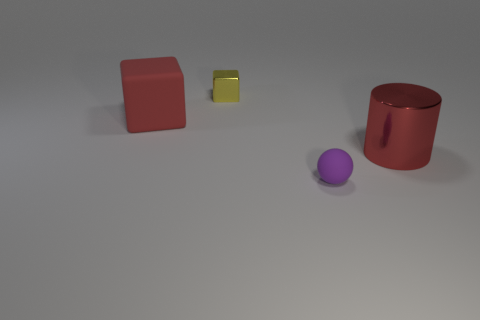The cube that is the same material as the large cylinder is what size?
Your response must be concise. Small. Do the metal cylinder and the matte thing that is behind the tiny purple rubber object have the same size?
Ensure brevity in your answer.  Yes. The object that is to the right of the yellow block and behind the small matte object is what color?
Keep it short and to the point. Red. How many things are either things to the left of the large shiny cylinder or things that are in front of the yellow metal block?
Offer a very short reply. 4. What is the color of the shiny object behind the red object that is behind the large thing that is on the right side of the small cube?
Offer a terse response. Yellow. Is there another small thing that has the same shape as the tiny purple matte object?
Make the answer very short. No. What number of yellow things are there?
Your response must be concise. 1. What shape is the tiny matte thing?
Provide a short and direct response. Sphere. How many purple spheres have the same size as the red rubber block?
Your response must be concise. 0. Does the large red metallic object have the same shape as the small metal thing?
Your answer should be compact. No. 